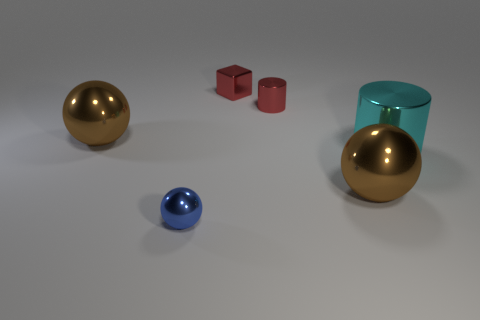Are there fewer small blue balls behind the tiny red cylinder than cyan cylinders?
Make the answer very short. Yes. How many matte objects are tiny cylinders or spheres?
Make the answer very short. 0. Does the tiny metal sphere have the same color as the metallic cube?
Provide a short and direct response. No. Is there any other thing that has the same color as the small cylinder?
Your response must be concise. Yes. Do the brown metal object left of the blue metallic ball and the tiny red object behind the small red metallic cylinder have the same shape?
Your response must be concise. No. How many things are purple cubes or metallic things left of the red block?
Provide a short and direct response. 2. Is the tiny red thing to the right of the small cube made of the same material as the large brown thing that is to the left of the small red metallic cylinder?
Your answer should be compact. Yes. There is a blue ball; how many red objects are right of it?
Give a very brief answer. 2. How many red objects are either tiny cylinders or large spheres?
Give a very brief answer. 1. There is a cube that is the same size as the red shiny cylinder; what is its material?
Provide a short and direct response. Metal. 